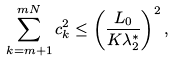Convert formula to latex. <formula><loc_0><loc_0><loc_500><loc_500>\sum _ { k = m + 1 } ^ { m N } c _ { k } ^ { 2 } \leq \left ( \frac { L _ { 0 } } { K \lambda _ { 2 } ^ { \ast } } \right ) ^ { 2 } ,</formula> 